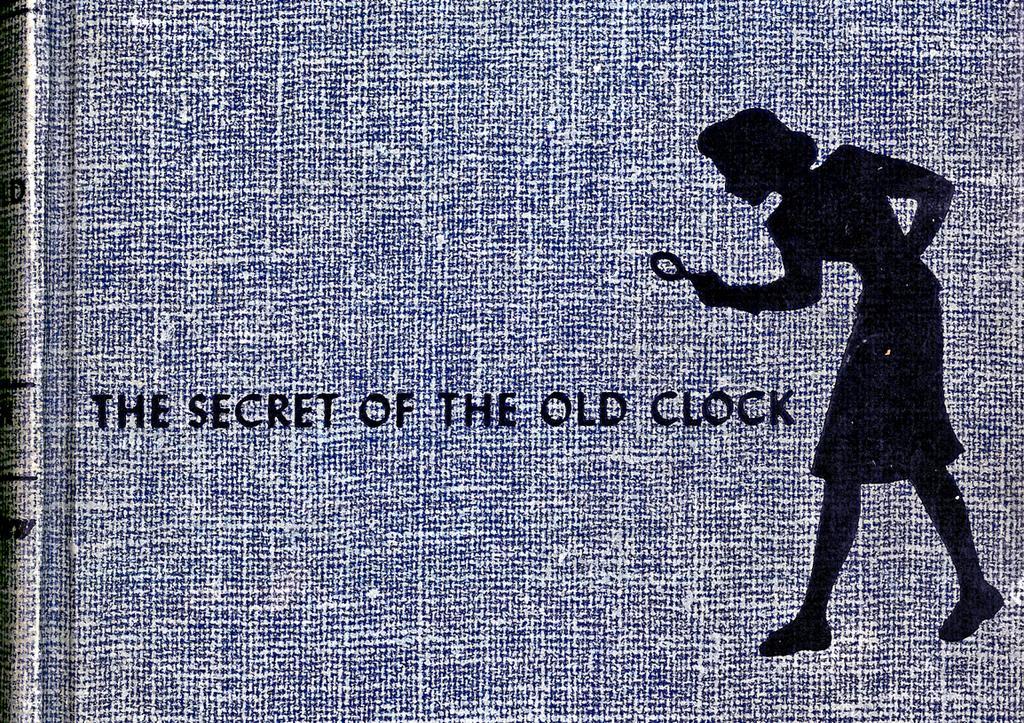In one or two sentences, can you explain what this image depicts? In this image I can see blue colour thing and on it I can see a drawing and I can see something is written over here. 